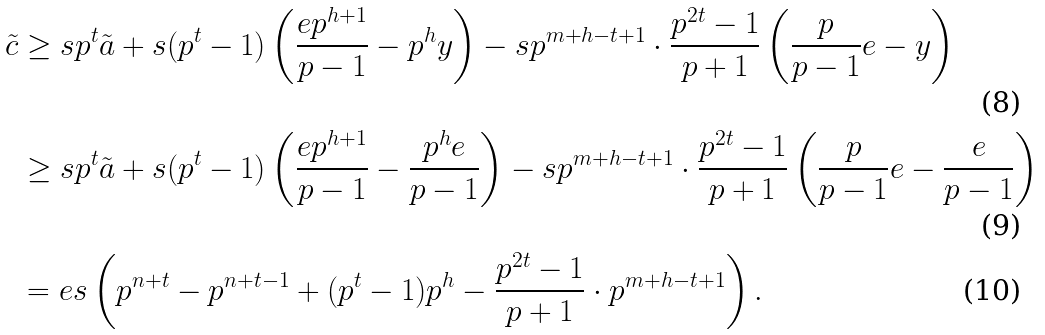Convert formula to latex. <formula><loc_0><loc_0><loc_500><loc_500>\tilde { c } & \geq s p ^ { t } \tilde { a } + s ( p ^ { t } - 1 ) \left ( \frac { e p ^ { h + 1 } } { p - 1 } - p ^ { h } y \right ) - s p ^ { m + h - t + 1 } \cdot \frac { p ^ { 2 t } - 1 } { p + 1 } \left ( \frac { p } { p - 1 } e - y \right ) \\ & \geq s p ^ { t } \tilde { a } + s ( p ^ { t } - 1 ) \left ( \frac { e p ^ { h + 1 } } { p - 1 } - \frac { p ^ { h } e } { p - 1 } \right ) - s p ^ { m + h - t + 1 } \cdot \frac { p ^ { 2 t } - 1 } { p + 1 } \left ( \frac { p } { p - 1 } e - \frac { e } { p - 1 } \right ) \\ & = e s \left ( p ^ { n + t } - p ^ { n + t - 1 } + ( p ^ { t } - 1 ) p ^ { h } - \frac { p ^ { 2 t } - 1 } { p + 1 } \cdot p ^ { m + h - t + 1 } \right ) .</formula> 